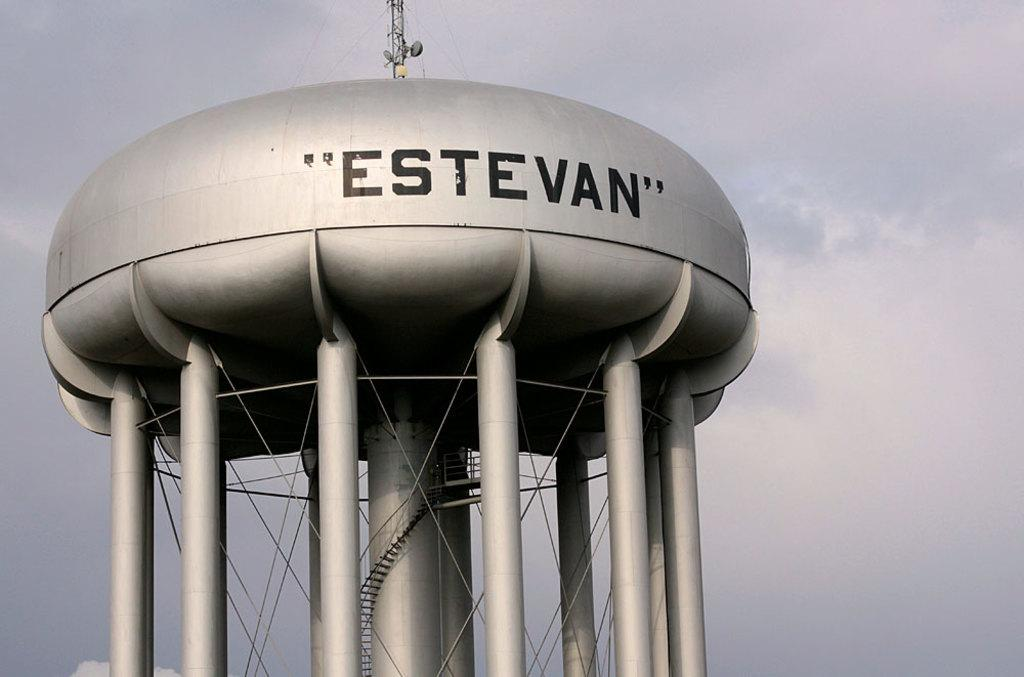<image>
Render a clear and concise summary of the photo. A silver water tank is showing the name of Estevan on its side. 